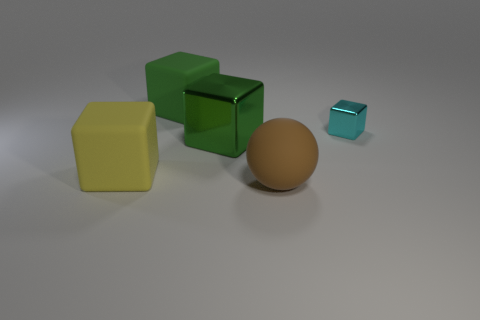What number of objects are either large cubes or big matte objects? There are three large objects that can be described as cubes, with two appearing to have a matte finish. No other objects in the image fit the description of either large cubes or big matte objects, making the total count three. 